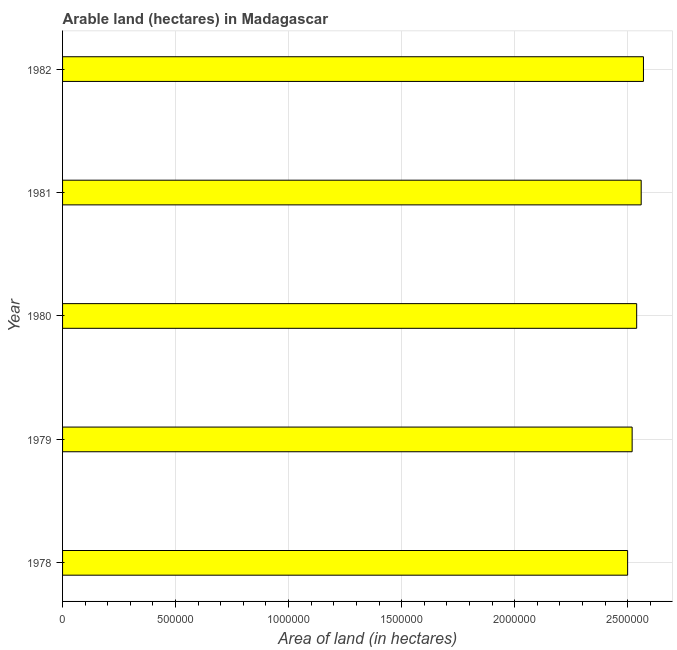Does the graph contain any zero values?
Provide a succinct answer. No. Does the graph contain grids?
Make the answer very short. Yes. What is the title of the graph?
Make the answer very short. Arable land (hectares) in Madagascar. What is the label or title of the X-axis?
Make the answer very short. Area of land (in hectares). What is the label or title of the Y-axis?
Make the answer very short. Year. What is the area of land in 1978?
Your response must be concise. 2.50e+06. Across all years, what is the maximum area of land?
Your answer should be compact. 2.57e+06. Across all years, what is the minimum area of land?
Offer a terse response. 2.50e+06. In which year was the area of land minimum?
Your answer should be compact. 1978. What is the sum of the area of land?
Your answer should be very brief. 1.27e+07. What is the average area of land per year?
Provide a short and direct response. 2.54e+06. What is the median area of land?
Offer a terse response. 2.54e+06. In how many years, is the area of land greater than 2500000 hectares?
Offer a terse response. 4. What is the difference between the highest and the second highest area of land?
Provide a short and direct response. 10000. In how many years, is the area of land greater than the average area of land taken over all years?
Offer a very short reply. 3. Are all the bars in the graph horizontal?
Offer a terse response. Yes. How many years are there in the graph?
Your response must be concise. 5. Are the values on the major ticks of X-axis written in scientific E-notation?
Make the answer very short. No. What is the Area of land (in hectares) in 1978?
Ensure brevity in your answer.  2.50e+06. What is the Area of land (in hectares) of 1979?
Your response must be concise. 2.52e+06. What is the Area of land (in hectares) in 1980?
Provide a short and direct response. 2.54e+06. What is the Area of land (in hectares) in 1981?
Provide a short and direct response. 2.56e+06. What is the Area of land (in hectares) of 1982?
Offer a very short reply. 2.57e+06. What is the difference between the Area of land (in hectares) in 1978 and 1979?
Provide a succinct answer. -2.00e+04. What is the difference between the Area of land (in hectares) in 1978 and 1982?
Keep it short and to the point. -7.00e+04. What is the difference between the Area of land (in hectares) in 1979 and 1980?
Make the answer very short. -2.00e+04. What is the difference between the Area of land (in hectares) in 1979 and 1981?
Provide a succinct answer. -4.00e+04. What is the ratio of the Area of land (in hectares) in 1978 to that in 1979?
Make the answer very short. 0.99. What is the ratio of the Area of land (in hectares) in 1979 to that in 1980?
Give a very brief answer. 0.99. What is the ratio of the Area of land (in hectares) in 1979 to that in 1981?
Provide a succinct answer. 0.98. What is the ratio of the Area of land (in hectares) in 1979 to that in 1982?
Ensure brevity in your answer.  0.98. What is the ratio of the Area of land (in hectares) in 1980 to that in 1981?
Ensure brevity in your answer.  0.99. What is the ratio of the Area of land (in hectares) in 1981 to that in 1982?
Your answer should be very brief. 1. 